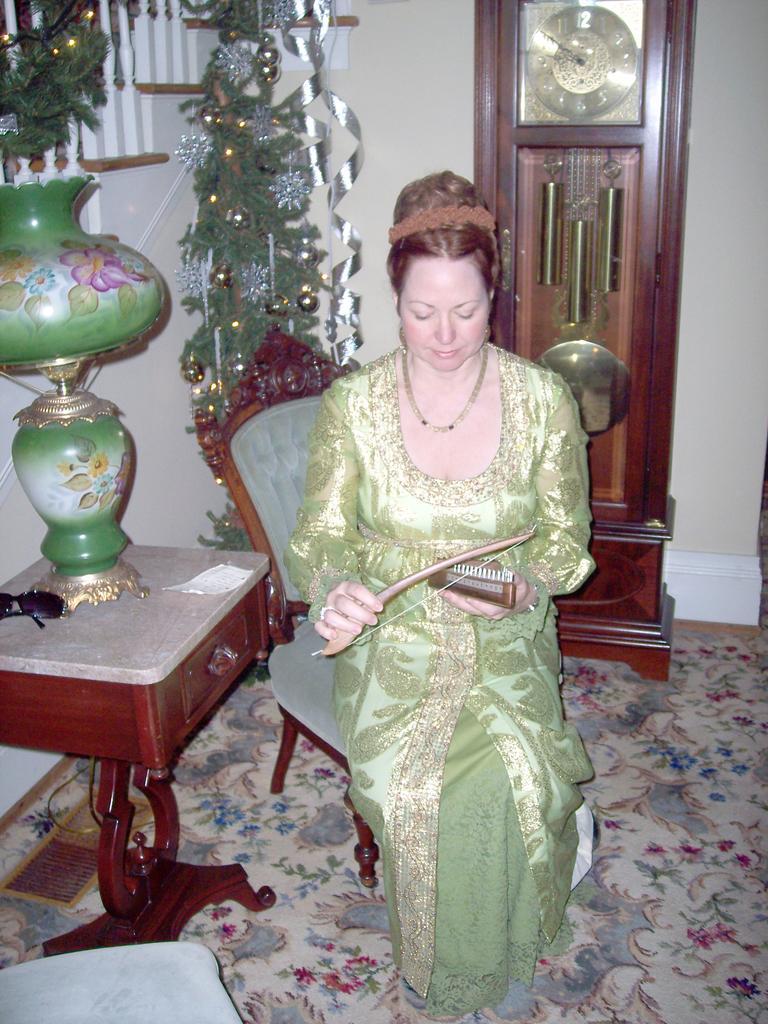Describe this image in one or two sentences. In this image, there is a woman sitting in the chair. She is wearing a green color dress. And playing a musical instrument. To the left, there is a table on which a flower vase is kept. In the background, there are stairs, plants, and a wall clock. At the bottom there is a floor mat on the floor. 